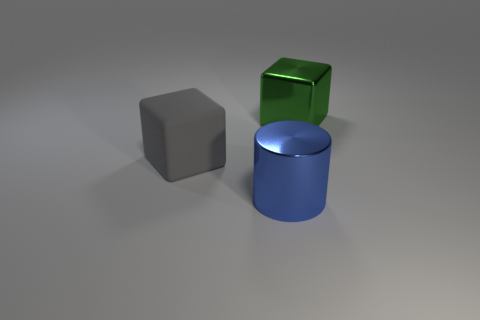Can you describe the lighting in the scene? The scene is softly lit with what appears to be diffuse, overhead lighting, creating gentle shadows on the sides of the objects opposite the light source. There's no harsh direct light, which gives the whole image a calm and uniform appearance. 